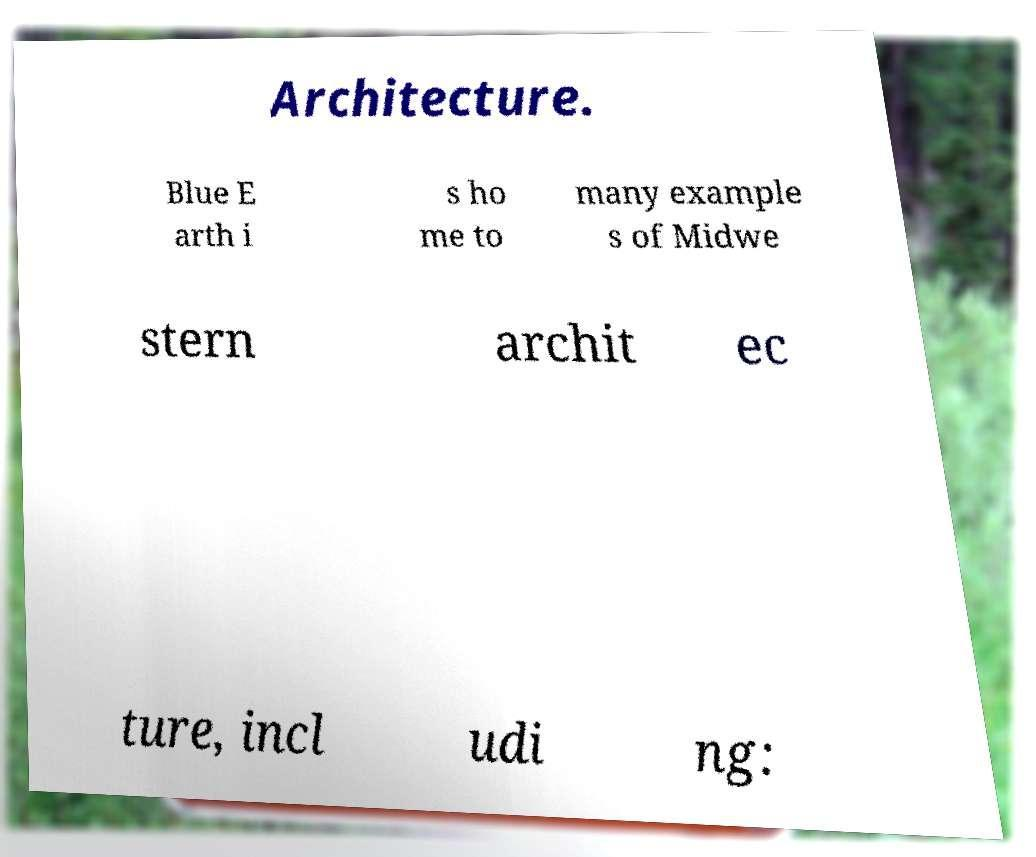I need the written content from this picture converted into text. Can you do that? Architecture. Blue E arth i s ho me to many example s of Midwe stern archit ec ture, incl udi ng: 